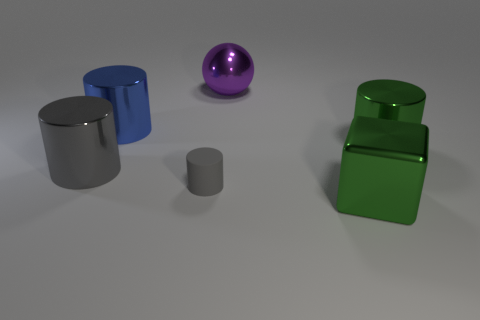What material is the large cylinder that is the same color as the big block?
Offer a very short reply. Metal. Is the number of green cylinders right of the purple shiny object less than the number of big purple metal spheres?
Give a very brief answer. No. Is the gray cylinder that is to the left of the rubber cylinder made of the same material as the green block?
Offer a very short reply. Yes. The big cube that is made of the same material as the blue cylinder is what color?
Your response must be concise. Green. Are there fewer gray matte cylinders that are behind the tiny rubber thing than shiny things that are behind the large blue thing?
Provide a short and direct response. Yes. There is a big object behind the large blue cylinder; does it have the same color as the cylinder that is to the right of the large purple object?
Give a very brief answer. No. Is there a big red cylinder that has the same material as the purple sphere?
Offer a very short reply. No. There is a green metallic object in front of the cylinder right of the large purple shiny ball; what size is it?
Keep it short and to the point. Large. Is the number of tiny objects greater than the number of gray blocks?
Provide a succinct answer. Yes. There is a green metal thing to the right of the metal block; does it have the same size as the small gray matte thing?
Ensure brevity in your answer.  No. 